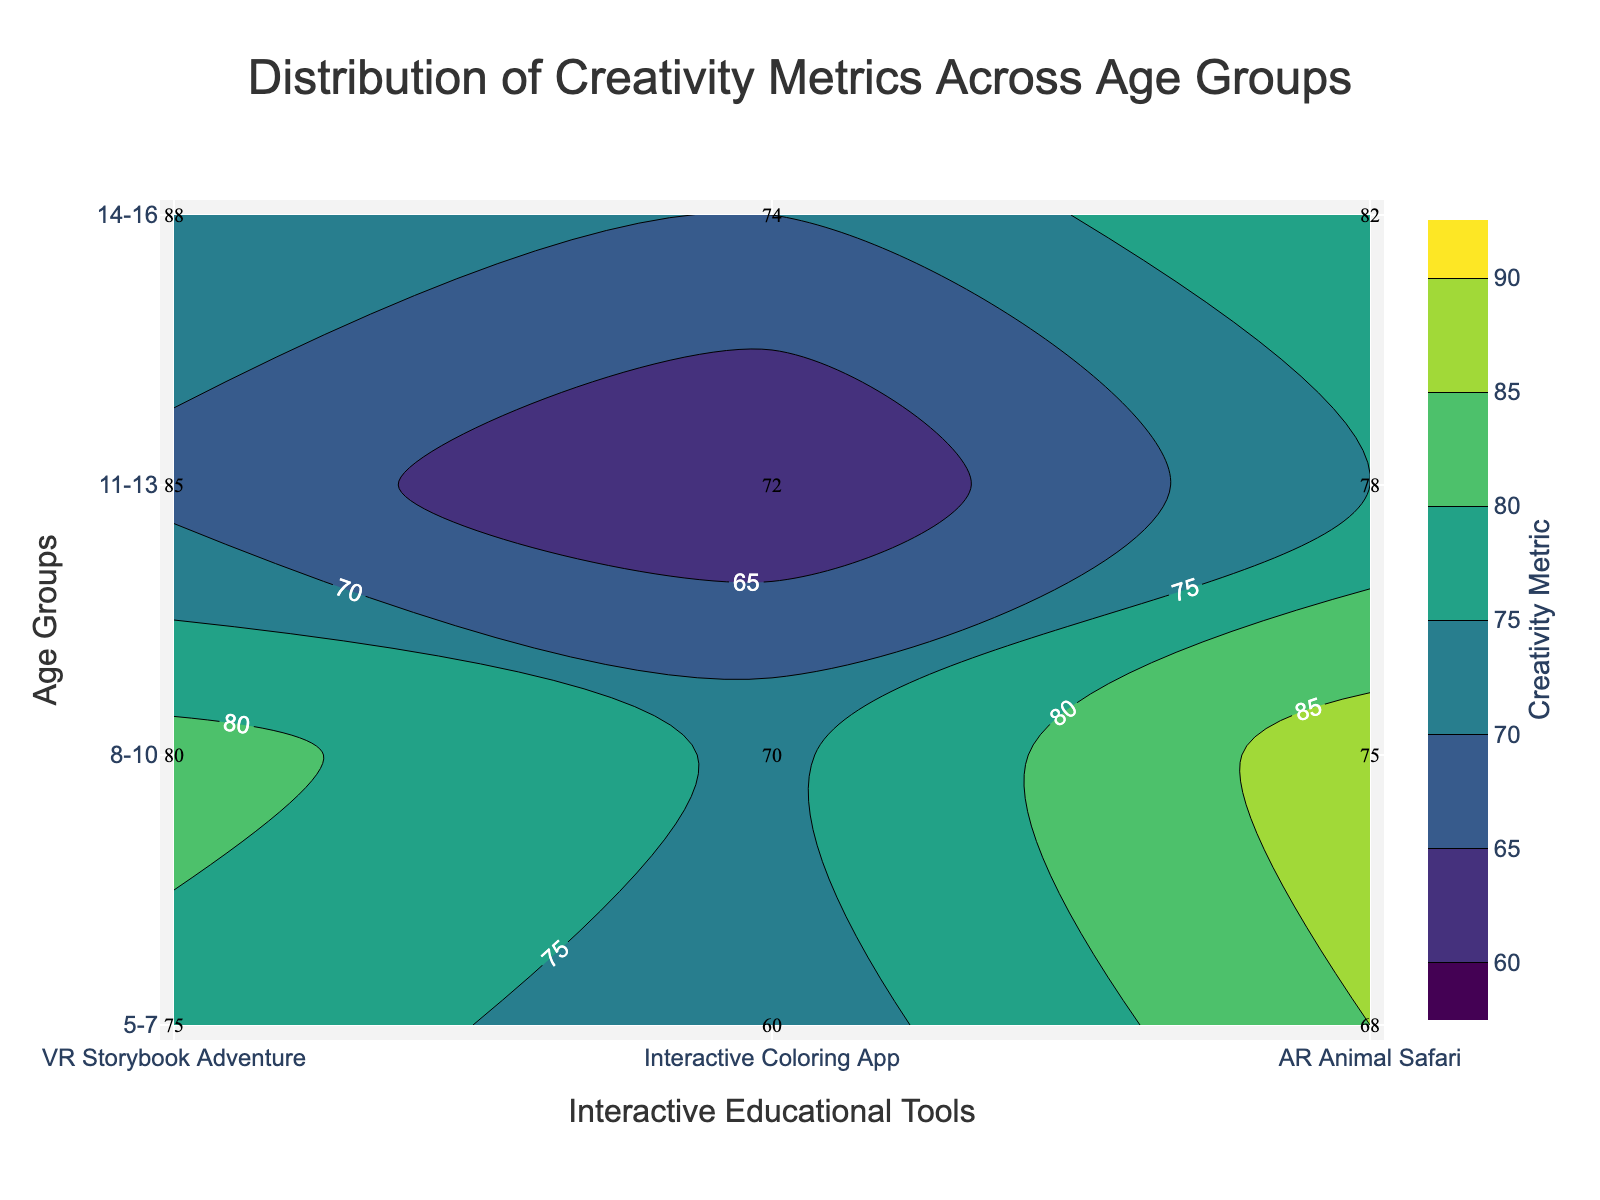What's the title of the figure? The title is usually found at the top of the figure, centered and prominently displayed. The title says "Distribution of Creativity Metrics Across Age Groups."
Answer: Distribution of Creativity Metrics Across Age Groups What age group shows the highest creativity metric for the VR Storybook Adventure tool? By looking at the vertical axis, locate the age group with the highest value along the contour line for the VR Storybook Adventure tool. It is the age group 14-16 with a metric of 88.
Answer: 14-16 Which interactive educational tool has the lowest creativity metric for children aged 5-7? Examine the contour labels for the 5-7 age group along the horizontal axis. The Interactive Coloring App has the lowest creativity metric of 60.
Answer: Interactive Coloring App For the AR Animal Safari tool, how does the creativity metric change across age groups? Trace the AR Animal Safari column from the bottom (younger age) to the top (older age). The metrics increase from 68 (5-7) to 75 (8-10), then to 78 (11-13), and finally to 82 (14-16).
Answer: Increases Which age group has the smallest range of creativity metrics across all interactive tools? For each age group, calculate the difference between the highest and lowest creativity metrics. The age group 11-13 has both the smallest and the largest values located closer together (85 - 72 = 13) as opposed to larger differences in other age groups.
Answer: 11-13 Between the VR Storybook Adventure and the Interactive Coloring App for children aged 8-10, which tool results in a higher creativity metric? Compare the contour labels for both tools in the 8-10 age group row. VR Storybook Adventure has a metric of 80, while Interactive Coloring App has a metric of 70, making VR Storybook Adventure higher.
Answer: VR Storybook Adventure What is the average creativity metric for the age group 14-16 across all tools? Sum the creativity metrics for the age group 14-16 for all three tools (88 + 74 + 82) and divide by the number of tools. The total is 244, and the average is 244/3 = ~81.33.
Answer: ~81.33 Which tool shows the highest improvement in creativity metric from age group 5-7 to age group 14-16? Calculate the difference in creativity metrics from age group 5-7 to 14-16 for each tool. VR Storybook Adventure: 88 - 75 = 13; Interactive Coloring App: 74 - 60 = 14; AR Animal Safari: 82 - 68 = 14. The Interactive Coloring App and AR Animal Safari both show the highest improvement of 14 points.
Answer: Interactive Coloring App and AR Animal Safari What's the median creativity metric for the Interactive Coloring App across all age groups? List the creativity metrics for the Interactive Coloring App (60, 70, 72, 74) and find the middle value. Since there are four values, the median is the average of the two middle values (70 and 72), which is (70+72)/2 = 71.
Answer: 71 